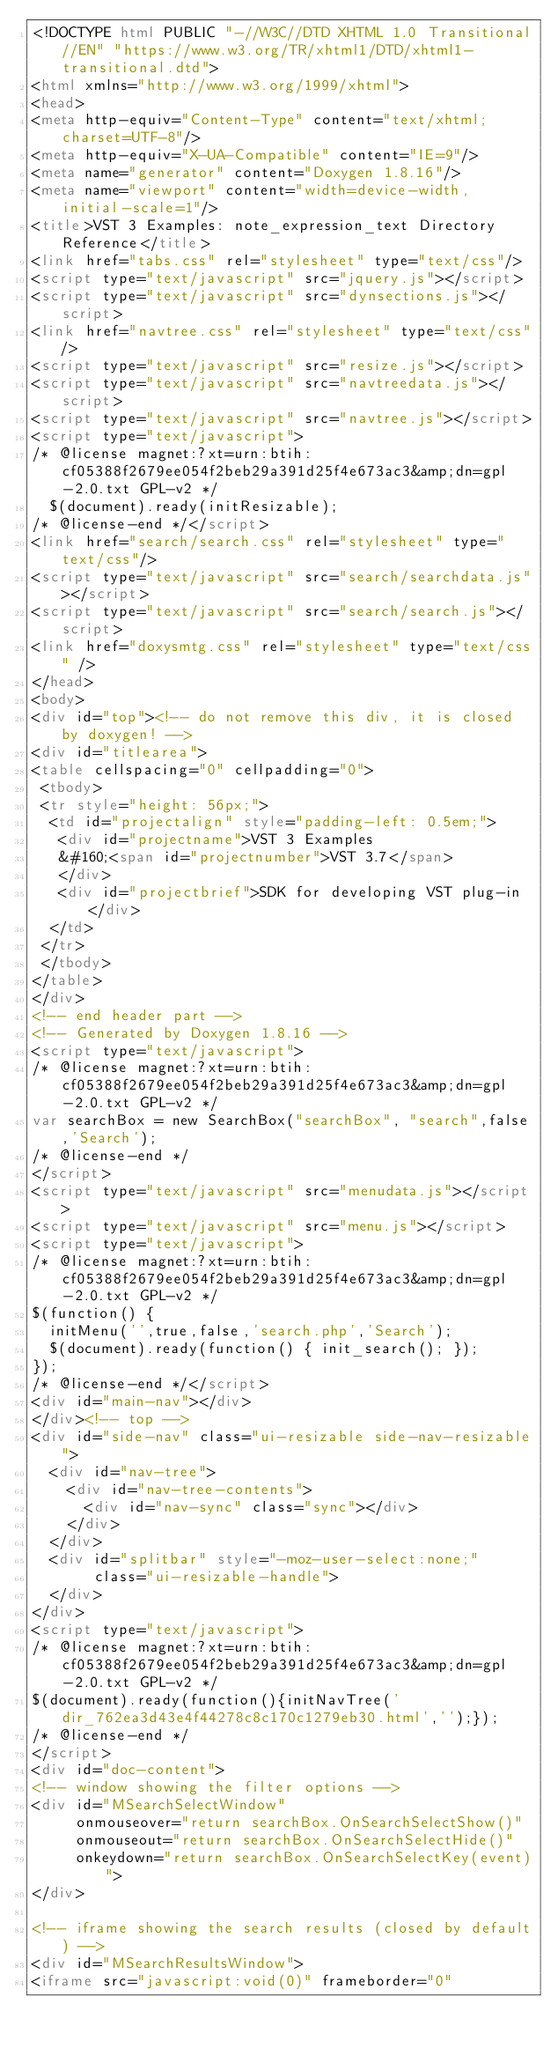Convert code to text. <code><loc_0><loc_0><loc_500><loc_500><_HTML_><!DOCTYPE html PUBLIC "-//W3C//DTD XHTML 1.0 Transitional//EN" "https://www.w3.org/TR/xhtml1/DTD/xhtml1-transitional.dtd">
<html xmlns="http://www.w3.org/1999/xhtml">
<head>
<meta http-equiv="Content-Type" content="text/xhtml;charset=UTF-8"/>
<meta http-equiv="X-UA-Compatible" content="IE=9"/>
<meta name="generator" content="Doxygen 1.8.16"/>
<meta name="viewport" content="width=device-width, initial-scale=1"/>
<title>VST 3 Examples: note_expression_text Directory Reference</title>
<link href="tabs.css" rel="stylesheet" type="text/css"/>
<script type="text/javascript" src="jquery.js"></script>
<script type="text/javascript" src="dynsections.js"></script>
<link href="navtree.css" rel="stylesheet" type="text/css"/>
<script type="text/javascript" src="resize.js"></script>
<script type="text/javascript" src="navtreedata.js"></script>
<script type="text/javascript" src="navtree.js"></script>
<script type="text/javascript">
/* @license magnet:?xt=urn:btih:cf05388f2679ee054f2beb29a391d25f4e673ac3&amp;dn=gpl-2.0.txt GPL-v2 */
  $(document).ready(initResizable);
/* @license-end */</script>
<link href="search/search.css" rel="stylesheet" type="text/css"/>
<script type="text/javascript" src="search/searchdata.js"></script>
<script type="text/javascript" src="search/search.js"></script>
<link href="doxysmtg.css" rel="stylesheet" type="text/css" />
</head>
<body>
<div id="top"><!-- do not remove this div, it is closed by doxygen! -->
<div id="titlearea">
<table cellspacing="0" cellpadding="0">
 <tbody>
 <tr style="height: 56px;">
  <td id="projectalign" style="padding-left: 0.5em;">
   <div id="projectname">VST 3 Examples
   &#160;<span id="projectnumber">VST 3.7</span>
   </div>
   <div id="projectbrief">SDK for developing VST plug-in</div>
  </td>
 </tr>
 </tbody>
</table>
</div>
<!-- end header part -->
<!-- Generated by Doxygen 1.8.16 -->
<script type="text/javascript">
/* @license magnet:?xt=urn:btih:cf05388f2679ee054f2beb29a391d25f4e673ac3&amp;dn=gpl-2.0.txt GPL-v2 */
var searchBox = new SearchBox("searchBox", "search",false,'Search');
/* @license-end */
</script>
<script type="text/javascript" src="menudata.js"></script>
<script type="text/javascript" src="menu.js"></script>
<script type="text/javascript">
/* @license magnet:?xt=urn:btih:cf05388f2679ee054f2beb29a391d25f4e673ac3&amp;dn=gpl-2.0.txt GPL-v2 */
$(function() {
  initMenu('',true,false,'search.php','Search');
  $(document).ready(function() { init_search(); });
});
/* @license-end */</script>
<div id="main-nav"></div>
</div><!-- top -->
<div id="side-nav" class="ui-resizable side-nav-resizable">
  <div id="nav-tree">
    <div id="nav-tree-contents">
      <div id="nav-sync" class="sync"></div>
    </div>
  </div>
  <div id="splitbar" style="-moz-user-select:none;" 
       class="ui-resizable-handle">
  </div>
</div>
<script type="text/javascript">
/* @license magnet:?xt=urn:btih:cf05388f2679ee054f2beb29a391d25f4e673ac3&amp;dn=gpl-2.0.txt GPL-v2 */
$(document).ready(function(){initNavTree('dir_762ea3d43e4f44278c8c170c1279eb30.html','');});
/* @license-end */
</script>
<div id="doc-content">
<!-- window showing the filter options -->
<div id="MSearchSelectWindow"
     onmouseover="return searchBox.OnSearchSelectShow()"
     onmouseout="return searchBox.OnSearchSelectHide()"
     onkeydown="return searchBox.OnSearchSelectKey(event)">
</div>

<!-- iframe showing the search results (closed by default) -->
<div id="MSearchResultsWindow">
<iframe src="javascript:void(0)" frameborder="0" </code> 